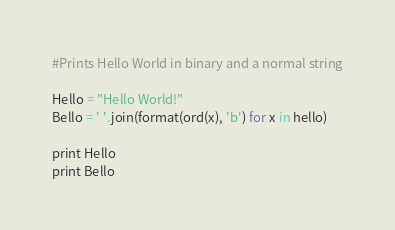<code> <loc_0><loc_0><loc_500><loc_500><_Python_>#Prints Hello World in binary and a normal string

Hello = "Hello World!"
Bello = ' '.join(format(ord(x), 'b') for x in hello)

print Hello
print Bello
</code> 